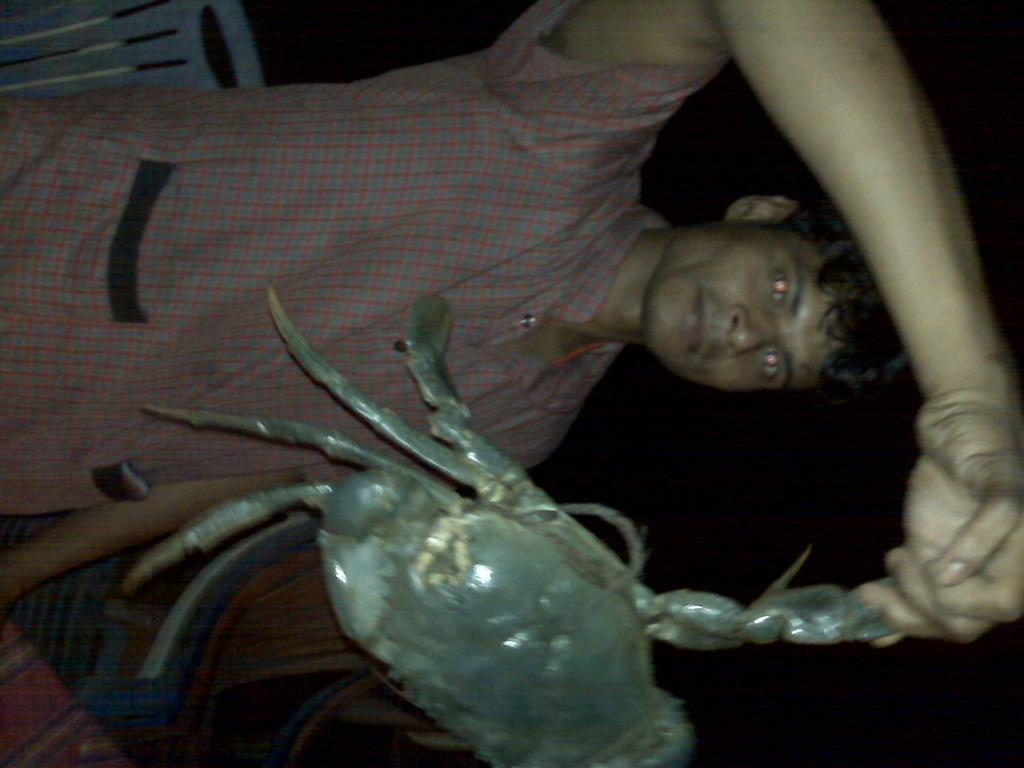What is the main subject of the image? The main subject of the image is a man standing. What is the man holding in his hand? The man is holding a crab in his hand. Can you describe the background of the image? The background of the image is dark. What type of brush is the man using to clean his throat in the image? There is no brush or throat-cleaning activity depicted in the image; the man is simply holding a crab. 